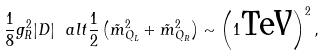Convert formula to latex. <formula><loc_0><loc_0><loc_500><loc_500>\frac { 1 } { 8 } g _ { R } ^ { 2 } | D | \ a l t \frac { 1 } { 2 } \left ( \tilde { m } _ { Q _ { L } } ^ { 2 } + \tilde { m } _ { Q _ { R } } ^ { 2 } \right ) \sim \left ( 1 \text {TeV} \right ) ^ { 2 } ,</formula> 